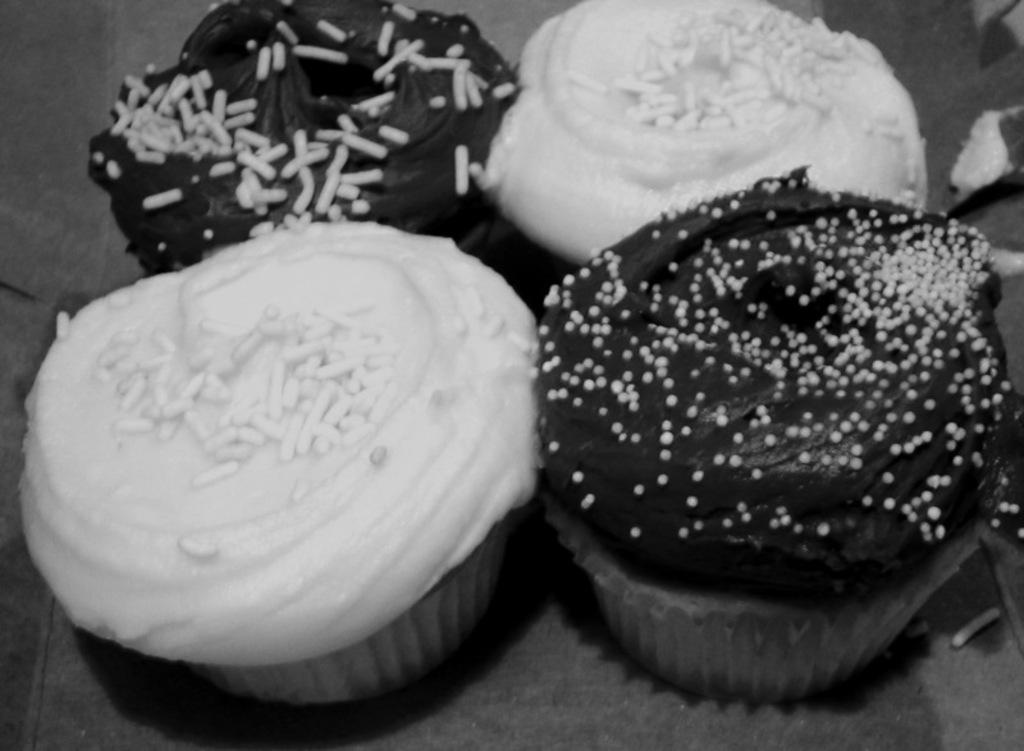How many cupcakes are visible in the image? There are 4 cupcakes in the image. What is the color scheme of the image? The image is black and white. What type of cord is connected to the dog in the image? There is no dog or cord present in the image; it only features cupcakes. 